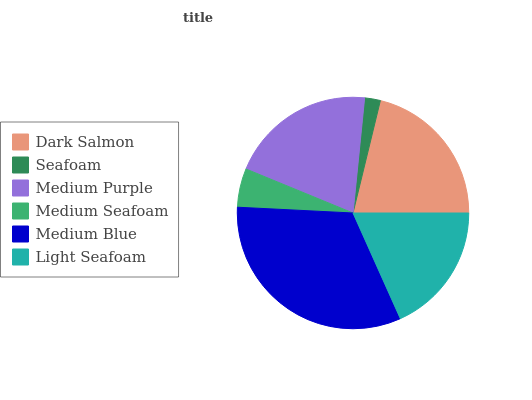Is Seafoam the minimum?
Answer yes or no. Yes. Is Medium Blue the maximum?
Answer yes or no. Yes. Is Medium Purple the minimum?
Answer yes or no. No. Is Medium Purple the maximum?
Answer yes or no. No. Is Medium Purple greater than Seafoam?
Answer yes or no. Yes. Is Seafoam less than Medium Purple?
Answer yes or no. Yes. Is Seafoam greater than Medium Purple?
Answer yes or no. No. Is Medium Purple less than Seafoam?
Answer yes or no. No. Is Medium Purple the high median?
Answer yes or no. Yes. Is Light Seafoam the low median?
Answer yes or no. Yes. Is Dark Salmon the high median?
Answer yes or no. No. Is Medium Purple the low median?
Answer yes or no. No. 